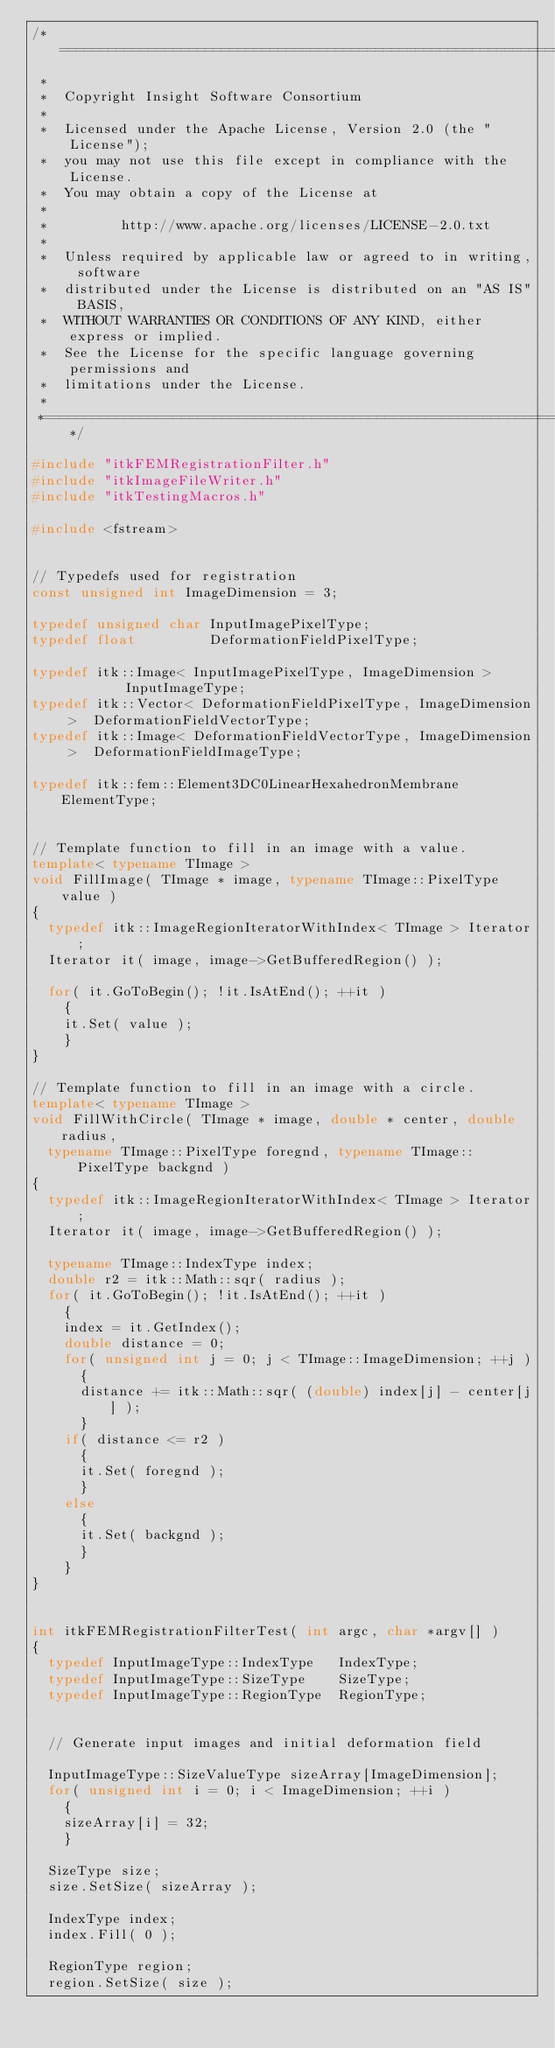Convert code to text. <code><loc_0><loc_0><loc_500><loc_500><_C++_>/*=========================================================================
 *
 *  Copyright Insight Software Consortium
 *
 *  Licensed under the Apache License, Version 2.0 (the "License");
 *  you may not use this file except in compliance with the License.
 *  You may obtain a copy of the License at
 *
 *         http://www.apache.org/licenses/LICENSE-2.0.txt
 *
 *  Unless required by applicable law or agreed to in writing, software
 *  distributed under the License is distributed on an "AS IS" BASIS,
 *  WITHOUT WARRANTIES OR CONDITIONS OF ANY KIND, either express or implied.
 *  See the License for the specific language governing permissions and
 *  limitations under the License.
 *
 *=========================================================================*/

#include "itkFEMRegistrationFilter.h"
#include "itkImageFileWriter.h"
#include "itkTestingMacros.h"

#include <fstream>


// Typedefs used for registration
const unsigned int ImageDimension = 3;

typedef unsigned char InputImagePixelType;
typedef float         DeformationFieldPixelType;

typedef itk::Image< InputImagePixelType, ImageDimension >         InputImageType;
typedef itk::Vector< DeformationFieldPixelType, ImageDimension >  DeformationFieldVectorType;
typedef itk::Image< DeformationFieldVectorType, ImageDimension >  DeformationFieldImageType;

typedef itk::fem::Element3DC0LinearHexahedronMembrane ElementType;


// Template function to fill in an image with a value.
template< typename TImage >
void FillImage( TImage * image, typename TImage::PixelType value )
{
  typedef itk::ImageRegionIteratorWithIndex< TImage > Iterator;
  Iterator it( image, image->GetBufferedRegion() );

  for( it.GoToBegin(); !it.IsAtEnd(); ++it )
    {
    it.Set( value );
    }
}

// Template function to fill in an image with a circle.
template< typename TImage >
void FillWithCircle( TImage * image, double * center, double radius,
  typename TImage::PixelType foregnd, typename TImage::PixelType backgnd )
{
  typedef itk::ImageRegionIteratorWithIndex< TImage > Iterator;
  Iterator it( image, image->GetBufferedRegion() );

  typename TImage::IndexType index;
  double r2 = itk::Math::sqr( radius );
  for( it.GoToBegin(); !it.IsAtEnd(); ++it )
    {
    index = it.GetIndex();
    double distance = 0;
    for( unsigned int j = 0; j < TImage::ImageDimension; ++j )
      {
      distance += itk::Math::sqr( (double) index[j] - center[j] );
      }
    if( distance <= r2 )
      {
      it.Set( foregnd );
      }
    else
      {
      it.Set( backgnd );
      }
    }
}


int itkFEMRegistrationFilterTest( int argc, char *argv[] )
{
  typedef InputImageType::IndexType   IndexType;
  typedef InputImageType::SizeType    SizeType;
  typedef InputImageType::RegionType  RegionType;


  // Generate input images and initial deformation field

  InputImageType::SizeValueType sizeArray[ImageDimension];
  for( unsigned int i = 0; i < ImageDimension; ++i )
    {
    sizeArray[i] = 32;
    }

  SizeType size;
  size.SetSize( sizeArray );

  IndexType index;
  index.Fill( 0 );

  RegionType region;
  region.SetSize( size );</code> 